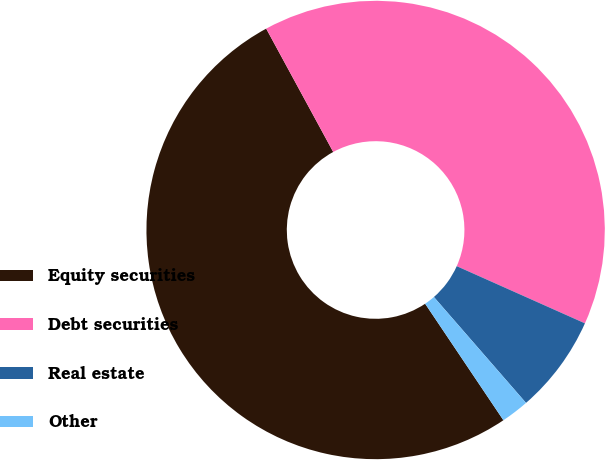Convert chart to OTSL. <chart><loc_0><loc_0><loc_500><loc_500><pie_chart><fcel>Equity securities<fcel>Debt securities<fcel>Real estate<fcel>Other<nl><fcel>51.49%<fcel>39.6%<fcel>6.93%<fcel>1.98%<nl></chart> 